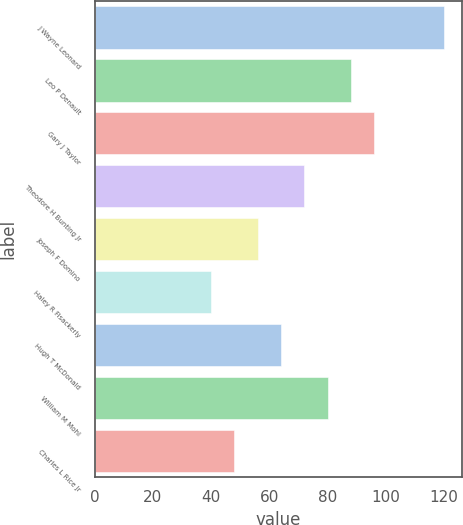Convert chart. <chart><loc_0><loc_0><loc_500><loc_500><bar_chart><fcel>J Wayne Leonard<fcel>Leo P Denault<fcel>Gary J Taylor<fcel>Theodore H Bunting Jr<fcel>Joseph F Domino<fcel>Haley R Fisackerly<fcel>Hugh T McDonald<fcel>William M Mohl<fcel>Charles L Rice Jr<nl><fcel>120<fcel>88<fcel>96<fcel>72<fcel>56<fcel>40<fcel>64<fcel>80<fcel>48<nl></chart> 